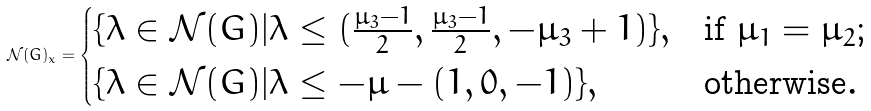<formula> <loc_0><loc_0><loc_500><loc_500>\mathcal { N } ( G ) _ { x } = \begin{cases} \{ \lambda \in \mathcal { N } ( G ) | \lambda \leq ( \frac { \mu _ { 3 } - 1 } { 2 } , \frac { \mu _ { 3 } - 1 } { 2 } , - \mu _ { 3 } + 1 ) \} , & \text {if $\mu_{1}=\mu_{2}$;} \\ \{ \lambda \in \mathcal { N } ( G ) | \lambda \leq - \mu - ( 1 , 0 , - 1 ) \} , & \text {otherwise} . \end{cases}</formula> 